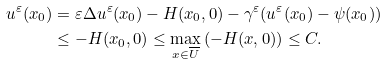<formula> <loc_0><loc_0><loc_500><loc_500>u ^ { \varepsilon } ( x _ { 0 } ) & = \varepsilon \Delta u ^ { \varepsilon } ( x _ { 0 } ) - H ( x _ { 0 } , 0 ) - \gamma ^ { \varepsilon } ( u ^ { \varepsilon } ( x _ { 0 } ) - \psi ( x _ { 0 } ) ) \\ & \leq - H ( x _ { 0 } , 0 ) \leq \max _ { x \in \overline { U } } \left ( - H ( x , 0 ) \right ) \leq C .</formula> 